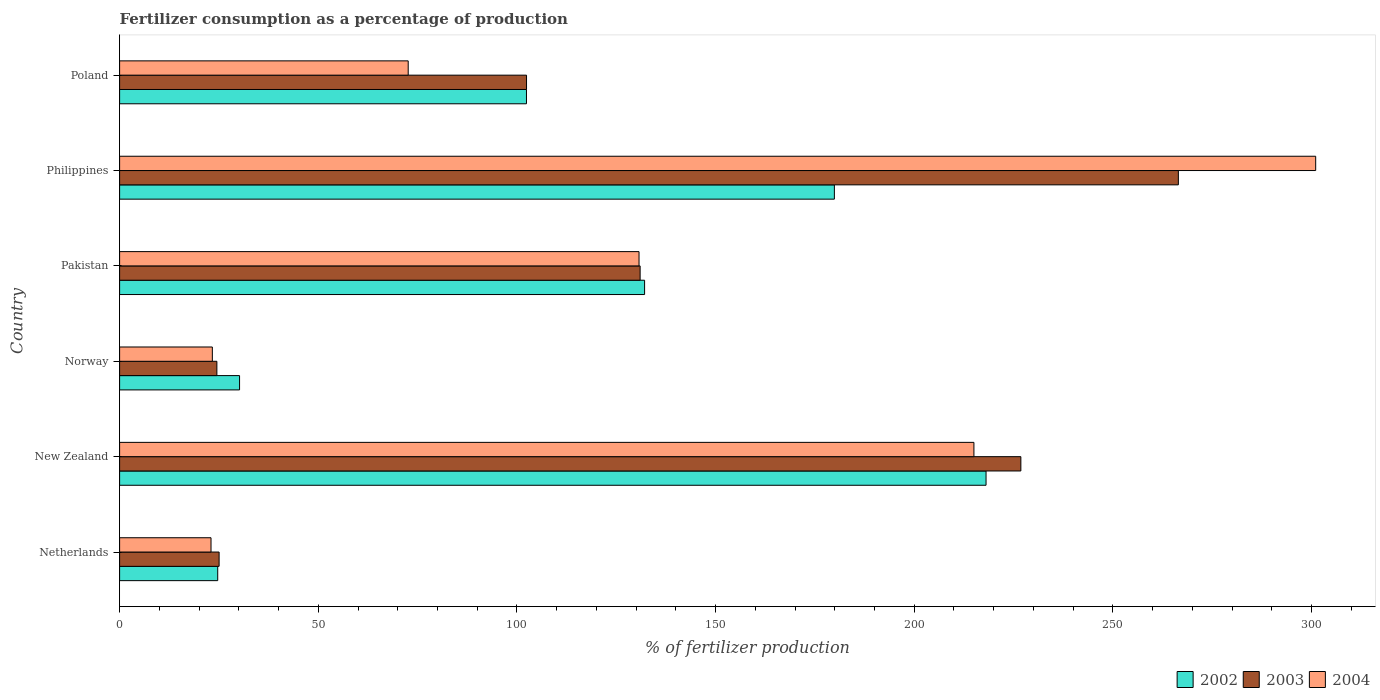How many different coloured bars are there?
Provide a short and direct response. 3. How many groups of bars are there?
Offer a terse response. 6. Are the number of bars per tick equal to the number of legend labels?
Give a very brief answer. Yes. How many bars are there on the 5th tick from the bottom?
Keep it short and to the point. 3. In how many cases, is the number of bars for a given country not equal to the number of legend labels?
Make the answer very short. 0. What is the percentage of fertilizers consumed in 2002 in Poland?
Your answer should be very brief. 102.4. Across all countries, what is the maximum percentage of fertilizers consumed in 2004?
Your answer should be compact. 301.04. Across all countries, what is the minimum percentage of fertilizers consumed in 2003?
Offer a terse response. 24.48. In which country was the percentage of fertilizers consumed in 2003 maximum?
Provide a short and direct response. Philippines. In which country was the percentage of fertilizers consumed in 2004 minimum?
Ensure brevity in your answer.  Netherlands. What is the total percentage of fertilizers consumed in 2002 in the graph?
Provide a succinct answer. 687.4. What is the difference between the percentage of fertilizers consumed in 2002 in Norway and that in Poland?
Keep it short and to the point. -72.21. What is the difference between the percentage of fertilizers consumed in 2002 in New Zealand and the percentage of fertilizers consumed in 2004 in Norway?
Provide a succinct answer. 194.73. What is the average percentage of fertilizers consumed in 2004 per country?
Provide a succinct answer. 127.63. What is the difference between the percentage of fertilizers consumed in 2003 and percentage of fertilizers consumed in 2004 in Poland?
Your response must be concise. 29.78. In how many countries, is the percentage of fertilizers consumed in 2002 greater than 40 %?
Give a very brief answer. 4. What is the ratio of the percentage of fertilizers consumed in 2003 in Pakistan to that in Poland?
Provide a succinct answer. 1.28. What is the difference between the highest and the second highest percentage of fertilizers consumed in 2002?
Your answer should be compact. 38.18. What is the difference between the highest and the lowest percentage of fertilizers consumed in 2002?
Offer a terse response. 193.38. In how many countries, is the percentage of fertilizers consumed in 2002 greater than the average percentage of fertilizers consumed in 2002 taken over all countries?
Offer a terse response. 3. Are the values on the major ticks of X-axis written in scientific E-notation?
Your answer should be very brief. No. Does the graph contain any zero values?
Provide a short and direct response. No. How are the legend labels stacked?
Your response must be concise. Horizontal. What is the title of the graph?
Your response must be concise. Fertilizer consumption as a percentage of production. Does "1983" appear as one of the legend labels in the graph?
Offer a terse response. No. What is the label or title of the X-axis?
Your answer should be compact. % of fertilizer production. What is the % of fertilizer production in 2002 in Netherlands?
Your answer should be very brief. 24.7. What is the % of fertilizer production in 2003 in Netherlands?
Provide a short and direct response. 25.04. What is the % of fertilizer production of 2004 in Netherlands?
Ensure brevity in your answer.  23.01. What is the % of fertilizer production in 2002 in New Zealand?
Offer a very short reply. 218.08. What is the % of fertilizer production of 2003 in New Zealand?
Your answer should be very brief. 226.83. What is the % of fertilizer production of 2004 in New Zealand?
Provide a succinct answer. 215.02. What is the % of fertilizer production of 2002 in Norway?
Make the answer very short. 30.19. What is the % of fertilizer production of 2003 in Norway?
Give a very brief answer. 24.48. What is the % of fertilizer production in 2004 in Norway?
Ensure brevity in your answer.  23.34. What is the % of fertilizer production in 2002 in Pakistan?
Your answer should be compact. 132.13. What is the % of fertilizer production in 2003 in Pakistan?
Ensure brevity in your answer.  131.01. What is the % of fertilizer production of 2004 in Pakistan?
Your answer should be very brief. 130.73. What is the % of fertilizer production of 2002 in Philippines?
Your answer should be very brief. 179.9. What is the % of fertilizer production in 2003 in Philippines?
Provide a short and direct response. 266.48. What is the % of fertilizer production of 2004 in Philippines?
Your answer should be very brief. 301.04. What is the % of fertilizer production of 2002 in Poland?
Make the answer very short. 102.4. What is the % of fertilizer production of 2003 in Poland?
Make the answer very short. 102.42. What is the % of fertilizer production of 2004 in Poland?
Your answer should be compact. 72.64. Across all countries, what is the maximum % of fertilizer production in 2002?
Your answer should be compact. 218.08. Across all countries, what is the maximum % of fertilizer production of 2003?
Give a very brief answer. 266.48. Across all countries, what is the maximum % of fertilizer production in 2004?
Provide a short and direct response. 301.04. Across all countries, what is the minimum % of fertilizer production in 2002?
Your answer should be very brief. 24.7. Across all countries, what is the minimum % of fertilizer production in 2003?
Provide a short and direct response. 24.48. Across all countries, what is the minimum % of fertilizer production of 2004?
Make the answer very short. 23.01. What is the total % of fertilizer production in 2002 in the graph?
Your response must be concise. 687.4. What is the total % of fertilizer production in 2003 in the graph?
Give a very brief answer. 776.27. What is the total % of fertilizer production in 2004 in the graph?
Make the answer very short. 765.78. What is the difference between the % of fertilizer production of 2002 in Netherlands and that in New Zealand?
Your answer should be very brief. -193.38. What is the difference between the % of fertilizer production in 2003 in Netherlands and that in New Zealand?
Offer a very short reply. -201.79. What is the difference between the % of fertilizer production in 2004 in Netherlands and that in New Zealand?
Your answer should be compact. -192.01. What is the difference between the % of fertilizer production of 2002 in Netherlands and that in Norway?
Offer a terse response. -5.5. What is the difference between the % of fertilizer production in 2003 in Netherlands and that in Norway?
Ensure brevity in your answer.  0.56. What is the difference between the % of fertilizer production in 2004 in Netherlands and that in Norway?
Your answer should be very brief. -0.34. What is the difference between the % of fertilizer production of 2002 in Netherlands and that in Pakistan?
Ensure brevity in your answer.  -107.44. What is the difference between the % of fertilizer production in 2003 in Netherlands and that in Pakistan?
Give a very brief answer. -105.97. What is the difference between the % of fertilizer production in 2004 in Netherlands and that in Pakistan?
Make the answer very short. -107.73. What is the difference between the % of fertilizer production in 2002 in Netherlands and that in Philippines?
Make the answer very short. -155.2. What is the difference between the % of fertilizer production of 2003 in Netherlands and that in Philippines?
Make the answer very short. -241.43. What is the difference between the % of fertilizer production of 2004 in Netherlands and that in Philippines?
Give a very brief answer. -278.03. What is the difference between the % of fertilizer production in 2002 in Netherlands and that in Poland?
Provide a short and direct response. -77.71. What is the difference between the % of fertilizer production in 2003 in Netherlands and that in Poland?
Your response must be concise. -77.38. What is the difference between the % of fertilizer production of 2004 in Netherlands and that in Poland?
Provide a succinct answer. -49.63. What is the difference between the % of fertilizer production in 2002 in New Zealand and that in Norway?
Offer a very short reply. 187.88. What is the difference between the % of fertilizer production in 2003 in New Zealand and that in Norway?
Your answer should be compact. 202.35. What is the difference between the % of fertilizer production of 2004 in New Zealand and that in Norway?
Offer a terse response. 191.68. What is the difference between the % of fertilizer production in 2002 in New Zealand and that in Pakistan?
Make the answer very short. 85.94. What is the difference between the % of fertilizer production of 2003 in New Zealand and that in Pakistan?
Give a very brief answer. 95.82. What is the difference between the % of fertilizer production of 2004 in New Zealand and that in Pakistan?
Offer a terse response. 84.29. What is the difference between the % of fertilizer production of 2002 in New Zealand and that in Philippines?
Give a very brief answer. 38.18. What is the difference between the % of fertilizer production of 2003 in New Zealand and that in Philippines?
Your answer should be compact. -39.64. What is the difference between the % of fertilizer production in 2004 in New Zealand and that in Philippines?
Offer a very short reply. -86.02. What is the difference between the % of fertilizer production in 2002 in New Zealand and that in Poland?
Ensure brevity in your answer.  115.67. What is the difference between the % of fertilizer production of 2003 in New Zealand and that in Poland?
Make the answer very short. 124.41. What is the difference between the % of fertilizer production of 2004 in New Zealand and that in Poland?
Make the answer very short. 142.38. What is the difference between the % of fertilizer production in 2002 in Norway and that in Pakistan?
Provide a succinct answer. -101.94. What is the difference between the % of fertilizer production in 2003 in Norway and that in Pakistan?
Your answer should be very brief. -106.53. What is the difference between the % of fertilizer production of 2004 in Norway and that in Pakistan?
Keep it short and to the point. -107.39. What is the difference between the % of fertilizer production in 2002 in Norway and that in Philippines?
Offer a terse response. -149.71. What is the difference between the % of fertilizer production in 2003 in Norway and that in Philippines?
Offer a very short reply. -241.99. What is the difference between the % of fertilizer production of 2004 in Norway and that in Philippines?
Provide a succinct answer. -277.7. What is the difference between the % of fertilizer production in 2002 in Norway and that in Poland?
Give a very brief answer. -72.21. What is the difference between the % of fertilizer production of 2003 in Norway and that in Poland?
Your answer should be compact. -77.94. What is the difference between the % of fertilizer production in 2004 in Norway and that in Poland?
Offer a very short reply. -49.29. What is the difference between the % of fertilizer production in 2002 in Pakistan and that in Philippines?
Your answer should be compact. -47.77. What is the difference between the % of fertilizer production in 2003 in Pakistan and that in Philippines?
Ensure brevity in your answer.  -135.47. What is the difference between the % of fertilizer production of 2004 in Pakistan and that in Philippines?
Provide a short and direct response. -170.31. What is the difference between the % of fertilizer production in 2002 in Pakistan and that in Poland?
Your answer should be very brief. 29.73. What is the difference between the % of fertilizer production of 2003 in Pakistan and that in Poland?
Make the answer very short. 28.59. What is the difference between the % of fertilizer production of 2004 in Pakistan and that in Poland?
Your response must be concise. 58.1. What is the difference between the % of fertilizer production of 2002 in Philippines and that in Poland?
Offer a very short reply. 77.5. What is the difference between the % of fertilizer production in 2003 in Philippines and that in Poland?
Your response must be concise. 164.06. What is the difference between the % of fertilizer production of 2004 in Philippines and that in Poland?
Give a very brief answer. 228.4. What is the difference between the % of fertilizer production in 2002 in Netherlands and the % of fertilizer production in 2003 in New Zealand?
Provide a succinct answer. -202.14. What is the difference between the % of fertilizer production in 2002 in Netherlands and the % of fertilizer production in 2004 in New Zealand?
Provide a succinct answer. -190.33. What is the difference between the % of fertilizer production in 2003 in Netherlands and the % of fertilizer production in 2004 in New Zealand?
Provide a succinct answer. -189.98. What is the difference between the % of fertilizer production of 2002 in Netherlands and the % of fertilizer production of 2003 in Norway?
Your answer should be very brief. 0.21. What is the difference between the % of fertilizer production of 2002 in Netherlands and the % of fertilizer production of 2004 in Norway?
Your answer should be compact. 1.35. What is the difference between the % of fertilizer production in 2003 in Netherlands and the % of fertilizer production in 2004 in Norway?
Keep it short and to the point. 1.7. What is the difference between the % of fertilizer production in 2002 in Netherlands and the % of fertilizer production in 2003 in Pakistan?
Offer a terse response. -106.31. What is the difference between the % of fertilizer production of 2002 in Netherlands and the % of fertilizer production of 2004 in Pakistan?
Ensure brevity in your answer.  -106.04. What is the difference between the % of fertilizer production in 2003 in Netherlands and the % of fertilizer production in 2004 in Pakistan?
Provide a short and direct response. -105.69. What is the difference between the % of fertilizer production of 2002 in Netherlands and the % of fertilizer production of 2003 in Philippines?
Provide a succinct answer. -241.78. What is the difference between the % of fertilizer production in 2002 in Netherlands and the % of fertilizer production in 2004 in Philippines?
Offer a terse response. -276.34. What is the difference between the % of fertilizer production in 2003 in Netherlands and the % of fertilizer production in 2004 in Philippines?
Offer a very short reply. -276. What is the difference between the % of fertilizer production of 2002 in Netherlands and the % of fertilizer production of 2003 in Poland?
Provide a succinct answer. -77.72. What is the difference between the % of fertilizer production of 2002 in Netherlands and the % of fertilizer production of 2004 in Poland?
Offer a terse response. -47.94. What is the difference between the % of fertilizer production of 2003 in Netherlands and the % of fertilizer production of 2004 in Poland?
Your answer should be very brief. -47.59. What is the difference between the % of fertilizer production of 2002 in New Zealand and the % of fertilizer production of 2003 in Norway?
Give a very brief answer. 193.59. What is the difference between the % of fertilizer production in 2002 in New Zealand and the % of fertilizer production in 2004 in Norway?
Keep it short and to the point. 194.73. What is the difference between the % of fertilizer production of 2003 in New Zealand and the % of fertilizer production of 2004 in Norway?
Offer a very short reply. 203.49. What is the difference between the % of fertilizer production of 2002 in New Zealand and the % of fertilizer production of 2003 in Pakistan?
Provide a short and direct response. 87.07. What is the difference between the % of fertilizer production in 2002 in New Zealand and the % of fertilizer production in 2004 in Pakistan?
Make the answer very short. 87.34. What is the difference between the % of fertilizer production of 2003 in New Zealand and the % of fertilizer production of 2004 in Pakistan?
Provide a short and direct response. 96.1. What is the difference between the % of fertilizer production in 2002 in New Zealand and the % of fertilizer production in 2003 in Philippines?
Your answer should be very brief. -48.4. What is the difference between the % of fertilizer production of 2002 in New Zealand and the % of fertilizer production of 2004 in Philippines?
Ensure brevity in your answer.  -82.96. What is the difference between the % of fertilizer production in 2003 in New Zealand and the % of fertilizer production in 2004 in Philippines?
Keep it short and to the point. -74.21. What is the difference between the % of fertilizer production in 2002 in New Zealand and the % of fertilizer production in 2003 in Poland?
Provide a succinct answer. 115.66. What is the difference between the % of fertilizer production in 2002 in New Zealand and the % of fertilizer production in 2004 in Poland?
Ensure brevity in your answer.  145.44. What is the difference between the % of fertilizer production in 2003 in New Zealand and the % of fertilizer production in 2004 in Poland?
Offer a terse response. 154.2. What is the difference between the % of fertilizer production of 2002 in Norway and the % of fertilizer production of 2003 in Pakistan?
Provide a succinct answer. -100.82. What is the difference between the % of fertilizer production in 2002 in Norway and the % of fertilizer production in 2004 in Pakistan?
Your answer should be compact. -100.54. What is the difference between the % of fertilizer production of 2003 in Norway and the % of fertilizer production of 2004 in Pakistan?
Keep it short and to the point. -106.25. What is the difference between the % of fertilizer production in 2002 in Norway and the % of fertilizer production in 2003 in Philippines?
Your answer should be compact. -236.28. What is the difference between the % of fertilizer production of 2002 in Norway and the % of fertilizer production of 2004 in Philippines?
Your answer should be very brief. -270.85. What is the difference between the % of fertilizer production of 2003 in Norway and the % of fertilizer production of 2004 in Philippines?
Provide a short and direct response. -276.56. What is the difference between the % of fertilizer production of 2002 in Norway and the % of fertilizer production of 2003 in Poland?
Your answer should be compact. -72.23. What is the difference between the % of fertilizer production of 2002 in Norway and the % of fertilizer production of 2004 in Poland?
Provide a short and direct response. -42.44. What is the difference between the % of fertilizer production of 2003 in Norway and the % of fertilizer production of 2004 in Poland?
Ensure brevity in your answer.  -48.15. What is the difference between the % of fertilizer production in 2002 in Pakistan and the % of fertilizer production in 2003 in Philippines?
Your answer should be very brief. -134.34. What is the difference between the % of fertilizer production of 2002 in Pakistan and the % of fertilizer production of 2004 in Philippines?
Give a very brief answer. -168.91. What is the difference between the % of fertilizer production in 2003 in Pakistan and the % of fertilizer production in 2004 in Philippines?
Your response must be concise. -170.03. What is the difference between the % of fertilizer production of 2002 in Pakistan and the % of fertilizer production of 2003 in Poland?
Give a very brief answer. 29.71. What is the difference between the % of fertilizer production of 2002 in Pakistan and the % of fertilizer production of 2004 in Poland?
Offer a terse response. 59.5. What is the difference between the % of fertilizer production of 2003 in Pakistan and the % of fertilizer production of 2004 in Poland?
Your answer should be very brief. 58.37. What is the difference between the % of fertilizer production in 2002 in Philippines and the % of fertilizer production in 2003 in Poland?
Keep it short and to the point. 77.48. What is the difference between the % of fertilizer production of 2002 in Philippines and the % of fertilizer production of 2004 in Poland?
Offer a terse response. 107.26. What is the difference between the % of fertilizer production in 2003 in Philippines and the % of fertilizer production in 2004 in Poland?
Offer a very short reply. 193.84. What is the average % of fertilizer production in 2002 per country?
Give a very brief answer. 114.57. What is the average % of fertilizer production of 2003 per country?
Make the answer very short. 129.38. What is the average % of fertilizer production in 2004 per country?
Provide a succinct answer. 127.63. What is the difference between the % of fertilizer production of 2002 and % of fertilizer production of 2003 in Netherlands?
Offer a very short reply. -0.35. What is the difference between the % of fertilizer production of 2002 and % of fertilizer production of 2004 in Netherlands?
Provide a succinct answer. 1.69. What is the difference between the % of fertilizer production in 2003 and % of fertilizer production in 2004 in Netherlands?
Keep it short and to the point. 2.04. What is the difference between the % of fertilizer production in 2002 and % of fertilizer production in 2003 in New Zealand?
Keep it short and to the point. -8.76. What is the difference between the % of fertilizer production in 2002 and % of fertilizer production in 2004 in New Zealand?
Your answer should be compact. 3.05. What is the difference between the % of fertilizer production in 2003 and % of fertilizer production in 2004 in New Zealand?
Your answer should be compact. 11.81. What is the difference between the % of fertilizer production of 2002 and % of fertilizer production of 2003 in Norway?
Offer a very short reply. 5.71. What is the difference between the % of fertilizer production in 2002 and % of fertilizer production in 2004 in Norway?
Your answer should be very brief. 6.85. What is the difference between the % of fertilizer production of 2003 and % of fertilizer production of 2004 in Norway?
Your answer should be compact. 1.14. What is the difference between the % of fertilizer production in 2002 and % of fertilizer production in 2003 in Pakistan?
Make the answer very short. 1.12. What is the difference between the % of fertilizer production of 2002 and % of fertilizer production of 2004 in Pakistan?
Your response must be concise. 1.4. What is the difference between the % of fertilizer production of 2003 and % of fertilizer production of 2004 in Pakistan?
Provide a short and direct response. 0.28. What is the difference between the % of fertilizer production of 2002 and % of fertilizer production of 2003 in Philippines?
Make the answer very short. -86.58. What is the difference between the % of fertilizer production in 2002 and % of fertilizer production in 2004 in Philippines?
Offer a very short reply. -121.14. What is the difference between the % of fertilizer production of 2003 and % of fertilizer production of 2004 in Philippines?
Provide a succinct answer. -34.56. What is the difference between the % of fertilizer production in 2002 and % of fertilizer production in 2003 in Poland?
Your response must be concise. -0.02. What is the difference between the % of fertilizer production of 2002 and % of fertilizer production of 2004 in Poland?
Ensure brevity in your answer.  29.77. What is the difference between the % of fertilizer production in 2003 and % of fertilizer production in 2004 in Poland?
Give a very brief answer. 29.78. What is the ratio of the % of fertilizer production in 2002 in Netherlands to that in New Zealand?
Give a very brief answer. 0.11. What is the ratio of the % of fertilizer production in 2003 in Netherlands to that in New Zealand?
Your answer should be compact. 0.11. What is the ratio of the % of fertilizer production in 2004 in Netherlands to that in New Zealand?
Provide a succinct answer. 0.11. What is the ratio of the % of fertilizer production of 2002 in Netherlands to that in Norway?
Your response must be concise. 0.82. What is the ratio of the % of fertilizer production of 2003 in Netherlands to that in Norway?
Offer a very short reply. 1.02. What is the ratio of the % of fertilizer production of 2004 in Netherlands to that in Norway?
Your answer should be compact. 0.99. What is the ratio of the % of fertilizer production of 2002 in Netherlands to that in Pakistan?
Offer a very short reply. 0.19. What is the ratio of the % of fertilizer production of 2003 in Netherlands to that in Pakistan?
Make the answer very short. 0.19. What is the ratio of the % of fertilizer production of 2004 in Netherlands to that in Pakistan?
Make the answer very short. 0.18. What is the ratio of the % of fertilizer production in 2002 in Netherlands to that in Philippines?
Offer a very short reply. 0.14. What is the ratio of the % of fertilizer production of 2003 in Netherlands to that in Philippines?
Provide a succinct answer. 0.09. What is the ratio of the % of fertilizer production of 2004 in Netherlands to that in Philippines?
Provide a succinct answer. 0.08. What is the ratio of the % of fertilizer production of 2002 in Netherlands to that in Poland?
Your answer should be compact. 0.24. What is the ratio of the % of fertilizer production of 2003 in Netherlands to that in Poland?
Offer a very short reply. 0.24. What is the ratio of the % of fertilizer production in 2004 in Netherlands to that in Poland?
Keep it short and to the point. 0.32. What is the ratio of the % of fertilizer production of 2002 in New Zealand to that in Norway?
Provide a short and direct response. 7.22. What is the ratio of the % of fertilizer production of 2003 in New Zealand to that in Norway?
Your answer should be compact. 9.26. What is the ratio of the % of fertilizer production of 2004 in New Zealand to that in Norway?
Your answer should be compact. 9.21. What is the ratio of the % of fertilizer production in 2002 in New Zealand to that in Pakistan?
Keep it short and to the point. 1.65. What is the ratio of the % of fertilizer production of 2003 in New Zealand to that in Pakistan?
Provide a short and direct response. 1.73. What is the ratio of the % of fertilizer production of 2004 in New Zealand to that in Pakistan?
Give a very brief answer. 1.64. What is the ratio of the % of fertilizer production of 2002 in New Zealand to that in Philippines?
Offer a terse response. 1.21. What is the ratio of the % of fertilizer production in 2003 in New Zealand to that in Philippines?
Your answer should be very brief. 0.85. What is the ratio of the % of fertilizer production of 2004 in New Zealand to that in Philippines?
Your answer should be compact. 0.71. What is the ratio of the % of fertilizer production of 2002 in New Zealand to that in Poland?
Your answer should be very brief. 2.13. What is the ratio of the % of fertilizer production in 2003 in New Zealand to that in Poland?
Ensure brevity in your answer.  2.21. What is the ratio of the % of fertilizer production of 2004 in New Zealand to that in Poland?
Provide a short and direct response. 2.96. What is the ratio of the % of fertilizer production of 2002 in Norway to that in Pakistan?
Give a very brief answer. 0.23. What is the ratio of the % of fertilizer production in 2003 in Norway to that in Pakistan?
Your answer should be compact. 0.19. What is the ratio of the % of fertilizer production in 2004 in Norway to that in Pakistan?
Give a very brief answer. 0.18. What is the ratio of the % of fertilizer production of 2002 in Norway to that in Philippines?
Give a very brief answer. 0.17. What is the ratio of the % of fertilizer production in 2003 in Norway to that in Philippines?
Your answer should be very brief. 0.09. What is the ratio of the % of fertilizer production in 2004 in Norway to that in Philippines?
Provide a succinct answer. 0.08. What is the ratio of the % of fertilizer production of 2002 in Norway to that in Poland?
Your answer should be very brief. 0.29. What is the ratio of the % of fertilizer production in 2003 in Norway to that in Poland?
Offer a very short reply. 0.24. What is the ratio of the % of fertilizer production in 2004 in Norway to that in Poland?
Provide a succinct answer. 0.32. What is the ratio of the % of fertilizer production in 2002 in Pakistan to that in Philippines?
Provide a succinct answer. 0.73. What is the ratio of the % of fertilizer production of 2003 in Pakistan to that in Philippines?
Provide a short and direct response. 0.49. What is the ratio of the % of fertilizer production in 2004 in Pakistan to that in Philippines?
Ensure brevity in your answer.  0.43. What is the ratio of the % of fertilizer production of 2002 in Pakistan to that in Poland?
Make the answer very short. 1.29. What is the ratio of the % of fertilizer production of 2003 in Pakistan to that in Poland?
Offer a very short reply. 1.28. What is the ratio of the % of fertilizer production in 2004 in Pakistan to that in Poland?
Your answer should be compact. 1.8. What is the ratio of the % of fertilizer production in 2002 in Philippines to that in Poland?
Keep it short and to the point. 1.76. What is the ratio of the % of fertilizer production of 2003 in Philippines to that in Poland?
Provide a succinct answer. 2.6. What is the ratio of the % of fertilizer production in 2004 in Philippines to that in Poland?
Offer a terse response. 4.14. What is the difference between the highest and the second highest % of fertilizer production in 2002?
Provide a succinct answer. 38.18. What is the difference between the highest and the second highest % of fertilizer production in 2003?
Provide a succinct answer. 39.64. What is the difference between the highest and the second highest % of fertilizer production in 2004?
Offer a very short reply. 86.02. What is the difference between the highest and the lowest % of fertilizer production of 2002?
Ensure brevity in your answer.  193.38. What is the difference between the highest and the lowest % of fertilizer production in 2003?
Your answer should be very brief. 241.99. What is the difference between the highest and the lowest % of fertilizer production of 2004?
Offer a terse response. 278.03. 